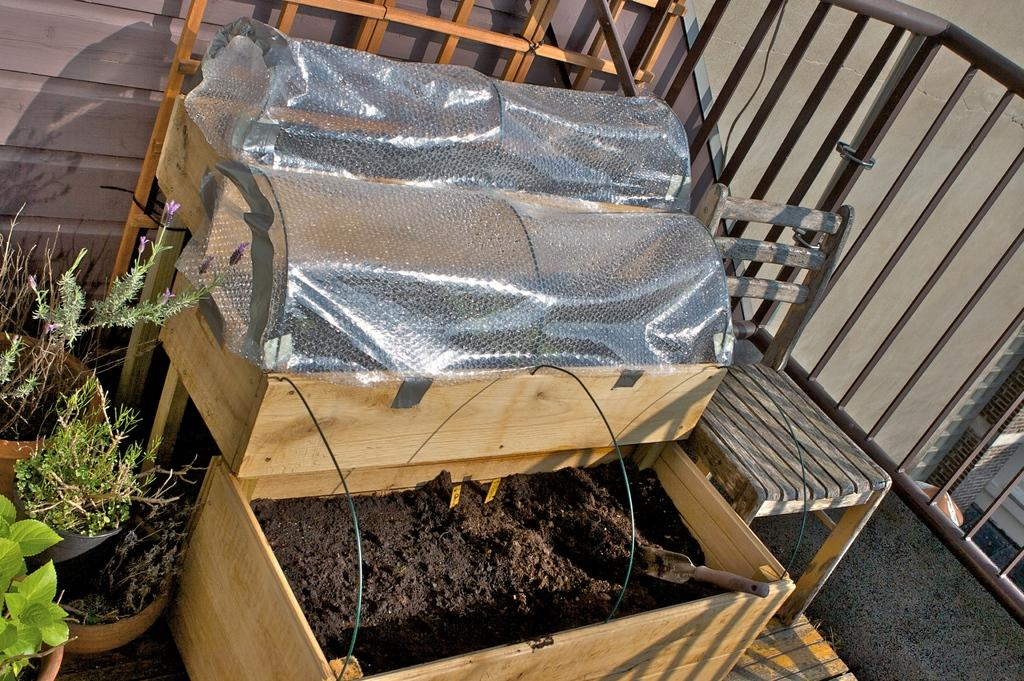What type of plants can be seen in the image? There are house plants in the image. What is located on the floor in the image? There is a chair on the floor in the image. What type of barrier is present in the image? There is a fence in the image. What type of structure is visible in the image? There is a wall in the image. Can you describe any objects in the image? There are some objects in the image, including a wooden box with mud and a spade. How many zebras can be seen in the image? There are no zebras present in the image. What type of furniture is visible in the image? The only furniture mentioned in the facts is a chair, so there is no other furniture visible in the image. 